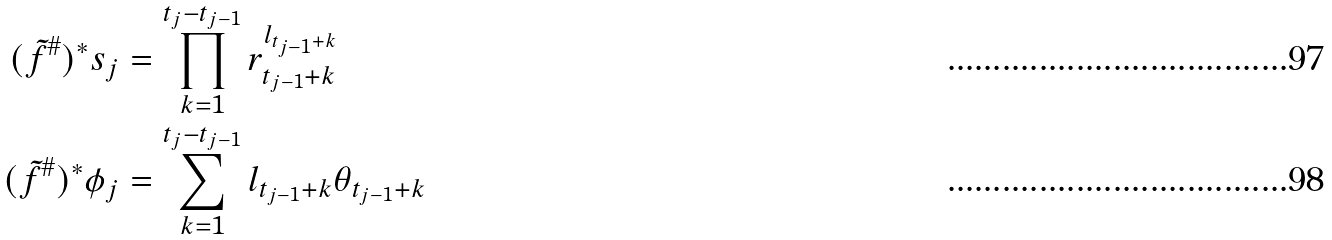<formula> <loc_0><loc_0><loc_500><loc_500>( \tilde { f } ^ { \# } ) ^ { * } s _ { j } & = \prod _ { k = 1 } ^ { t _ { j } - t _ { j - 1 } } r _ { t _ { j - 1 } + k } ^ { l _ { t _ { j - 1 } + k } } \\ ( \tilde { f } ^ { \# } ) ^ { * } \phi _ { j } & = \sum _ { k = 1 } ^ { t _ { j } - t _ { j - 1 } } l _ { t _ { j - 1 } + k } \theta _ { t _ { j - 1 } + k }</formula> 